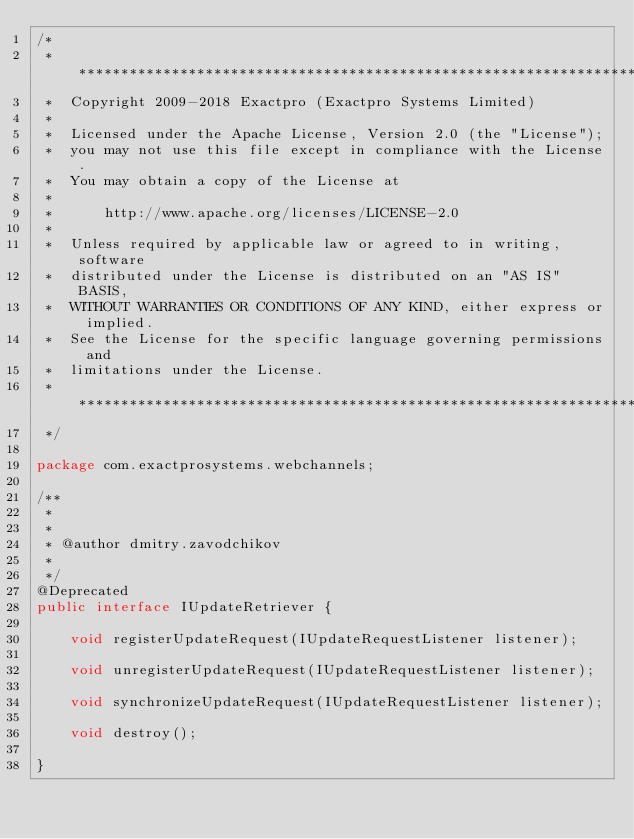<code> <loc_0><loc_0><loc_500><loc_500><_Java_>/*
 * *****************************************************************************
 *  Copyright 2009-2018 Exactpro (Exactpro Systems Limited)
 *
 *  Licensed under the Apache License, Version 2.0 (the "License");
 *  you may not use this file except in compliance with the License.
 *  You may obtain a copy of the License at
 *
 *      http://www.apache.org/licenses/LICENSE-2.0
 *
 *  Unless required by applicable law or agreed to in writing, software
 *  distributed under the License is distributed on an "AS IS" BASIS,
 *  WITHOUT WARRANTIES OR CONDITIONS OF ANY KIND, either express or implied.
 *  See the License for the specific language governing permissions and
 *  limitations under the License.
 * ****************************************************************************
 */

package com.exactprosystems.webchannels;

/**
 *
 * 
 * @author dmitry.zavodchikov
 *
 */
@Deprecated
public interface IUpdateRetriever {
	
	void registerUpdateRequest(IUpdateRequestListener listener);
	
	void unregisterUpdateRequest(IUpdateRequestListener listener);
	
	void synchronizeUpdateRequest(IUpdateRequestListener listener);
	
	void destroy();
	
}
</code> 